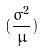<formula> <loc_0><loc_0><loc_500><loc_500>( \frac { \sigma ^ { 2 } } { \mu } )</formula> 